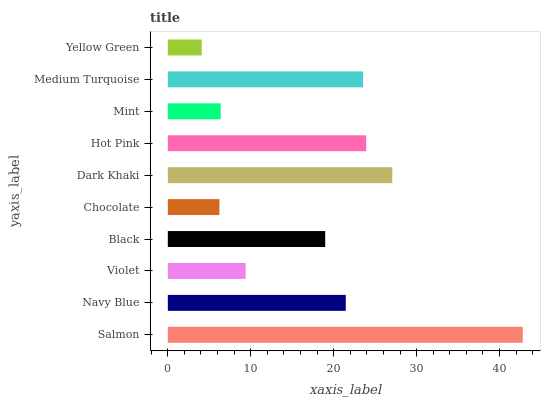Is Yellow Green the minimum?
Answer yes or no. Yes. Is Salmon the maximum?
Answer yes or no. Yes. Is Navy Blue the minimum?
Answer yes or no. No. Is Navy Blue the maximum?
Answer yes or no. No. Is Salmon greater than Navy Blue?
Answer yes or no. Yes. Is Navy Blue less than Salmon?
Answer yes or no. Yes. Is Navy Blue greater than Salmon?
Answer yes or no. No. Is Salmon less than Navy Blue?
Answer yes or no. No. Is Navy Blue the high median?
Answer yes or no. Yes. Is Black the low median?
Answer yes or no. Yes. Is Black the high median?
Answer yes or no. No. Is Medium Turquoise the low median?
Answer yes or no. No. 